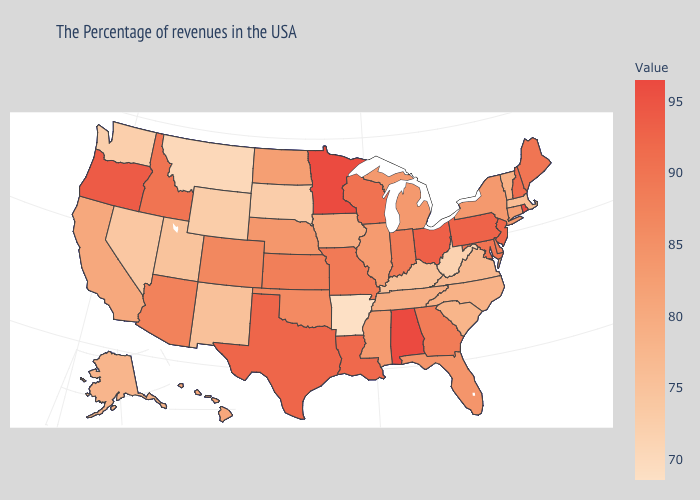Does North Dakota have a lower value than Kansas?
Answer briefly. Yes. Which states have the highest value in the USA?
Give a very brief answer. Alabama. Is the legend a continuous bar?
Write a very short answer. Yes. Among the states that border Michigan , which have the highest value?
Keep it brief. Ohio. Which states hav the highest value in the South?
Write a very short answer. Alabama. Which states hav the highest value in the MidWest?
Quick response, please. Minnesota. 